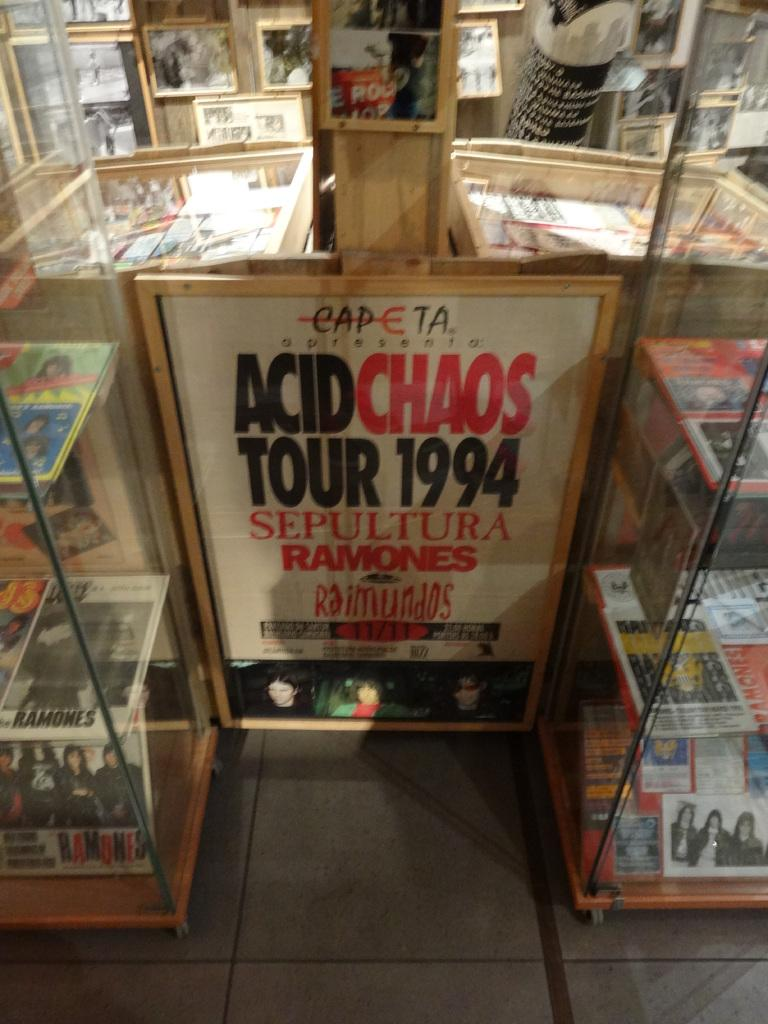<image>
Summarize the visual content of the image. Acid Chaos Tour poster in white, red and black from 1994. 